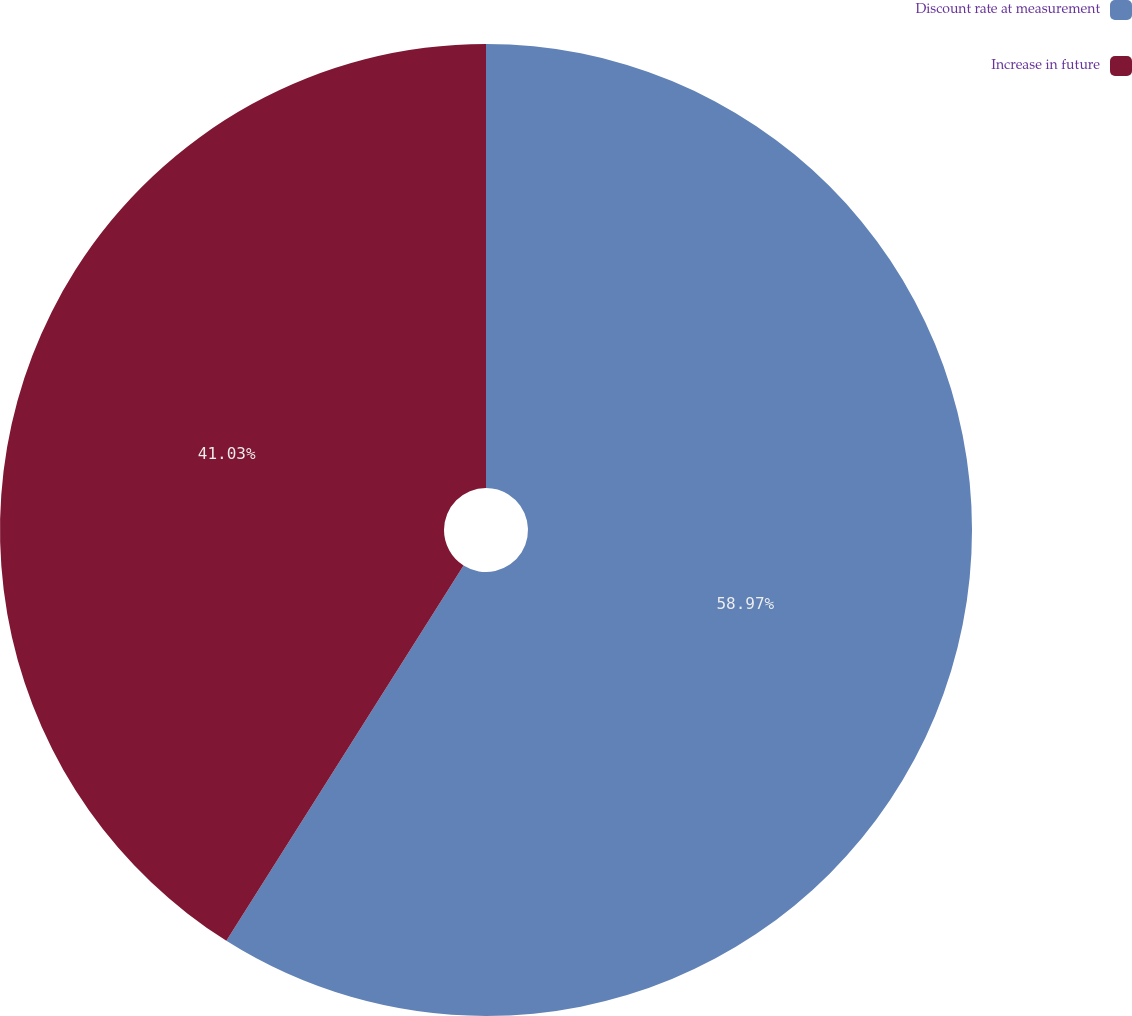Convert chart. <chart><loc_0><loc_0><loc_500><loc_500><pie_chart><fcel>Discount rate at measurement<fcel>Increase in future<nl><fcel>58.97%<fcel>41.03%<nl></chart> 